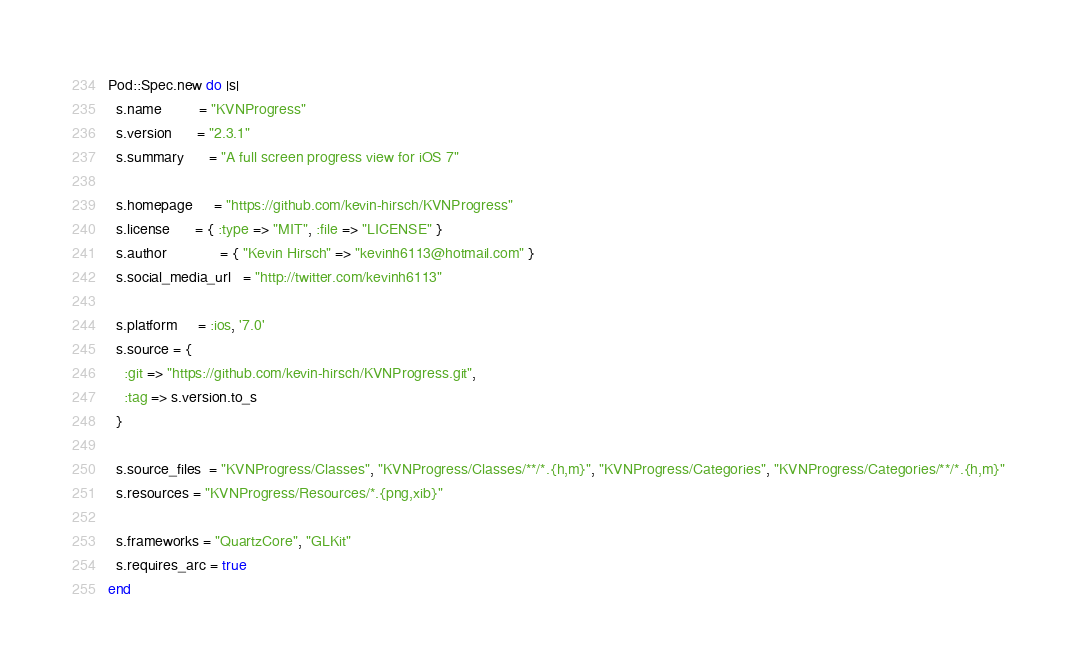<code> <loc_0><loc_0><loc_500><loc_500><_Ruby_>Pod::Spec.new do |s|
  s.name         = "KVNProgress"
  s.version      = "2.3.1"
  s.summary      = "A full screen progress view for iOS 7"

  s.homepage     = "https://github.com/kevin-hirsch/KVNProgress"
  s.license      = { :type => "MIT", :file => "LICENSE" }
  s.author             = { "Kevin Hirsch" => "kevinh6113@hotmail.com" }
  s.social_media_url   = "http://twitter.com/kevinh6113"

  s.platform     = :ios, '7.0'
  s.source = {
    :git => "https://github.com/kevin-hirsch/KVNProgress.git",
    :tag => s.version.to_s
  }

  s.source_files  = "KVNProgress/Classes", "KVNProgress/Classes/**/*.{h,m}", "KVNProgress/Categories", "KVNProgress/Categories/**/*.{h,m}"
  s.resources = "KVNProgress/Resources/*.{png,xib}"

  s.frameworks = "QuartzCore", "GLKit"
  s.requires_arc = true
end
</code> 